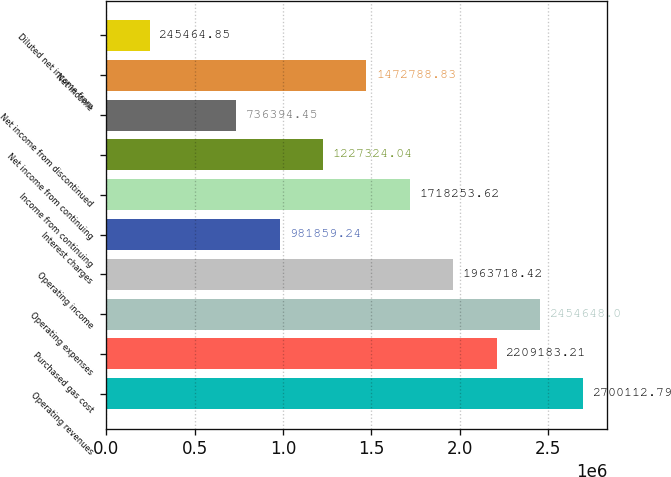Convert chart. <chart><loc_0><loc_0><loc_500><loc_500><bar_chart><fcel>Operating revenues<fcel>Purchased gas cost<fcel>Operating expenses<fcel>Operating income<fcel>Interest charges<fcel>Income from continuing<fcel>Net income from continuing<fcel>Net income from discontinued<fcel>Net income<fcel>Diluted net income from<nl><fcel>2.70011e+06<fcel>2.20918e+06<fcel>2.45465e+06<fcel>1.96372e+06<fcel>981859<fcel>1.71825e+06<fcel>1.22732e+06<fcel>736394<fcel>1.47279e+06<fcel>245465<nl></chart> 